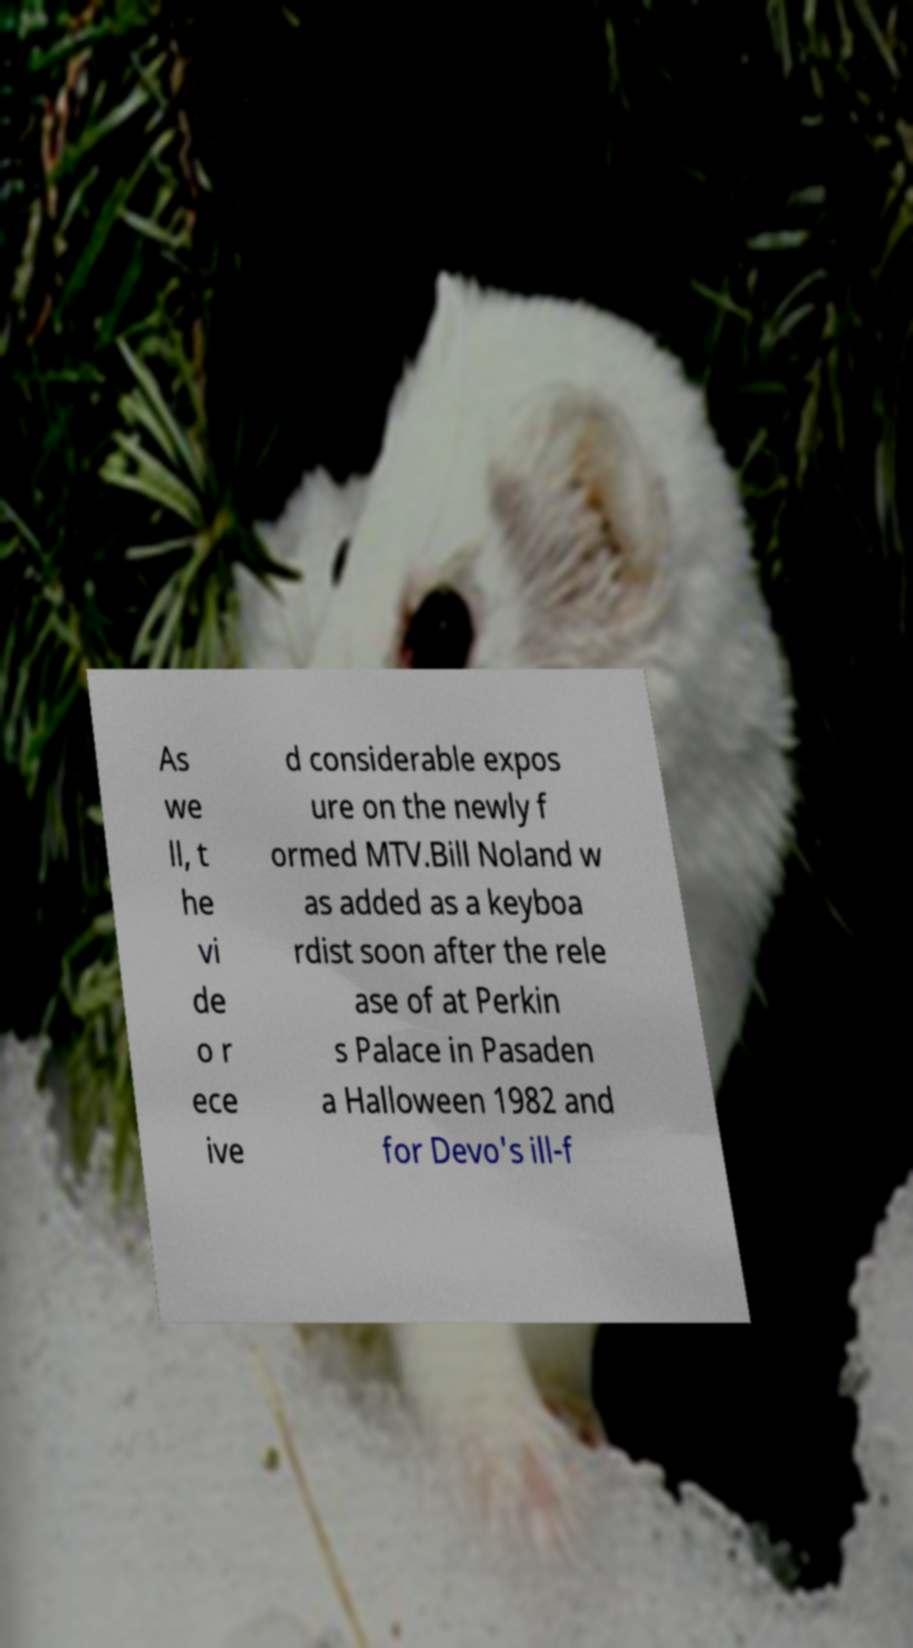I need the written content from this picture converted into text. Can you do that? As we ll, t he vi de o r ece ive d considerable expos ure on the newly f ormed MTV.Bill Noland w as added as a keyboa rdist soon after the rele ase of at Perkin s Palace in Pasaden a Halloween 1982 and for Devo's ill-f 